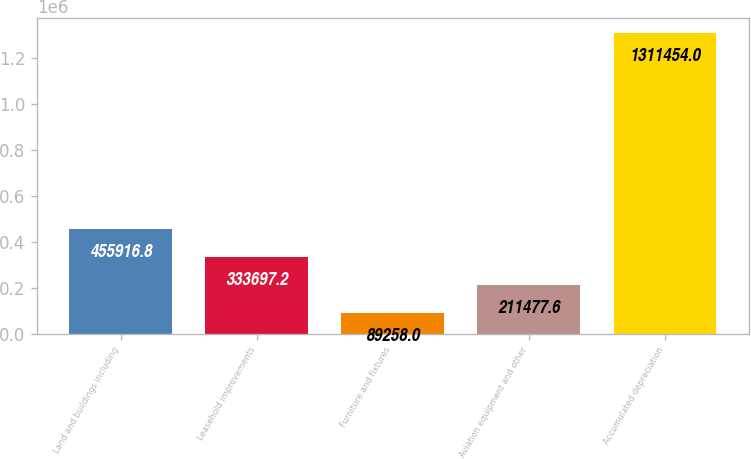Convert chart. <chart><loc_0><loc_0><loc_500><loc_500><bar_chart><fcel>Land and buildings including<fcel>Leasehold improvements<fcel>Furniture and fixtures<fcel>Aviation equipment and other<fcel>Accumulated depreciation<nl><fcel>455917<fcel>333697<fcel>89258<fcel>211478<fcel>1.31145e+06<nl></chart> 